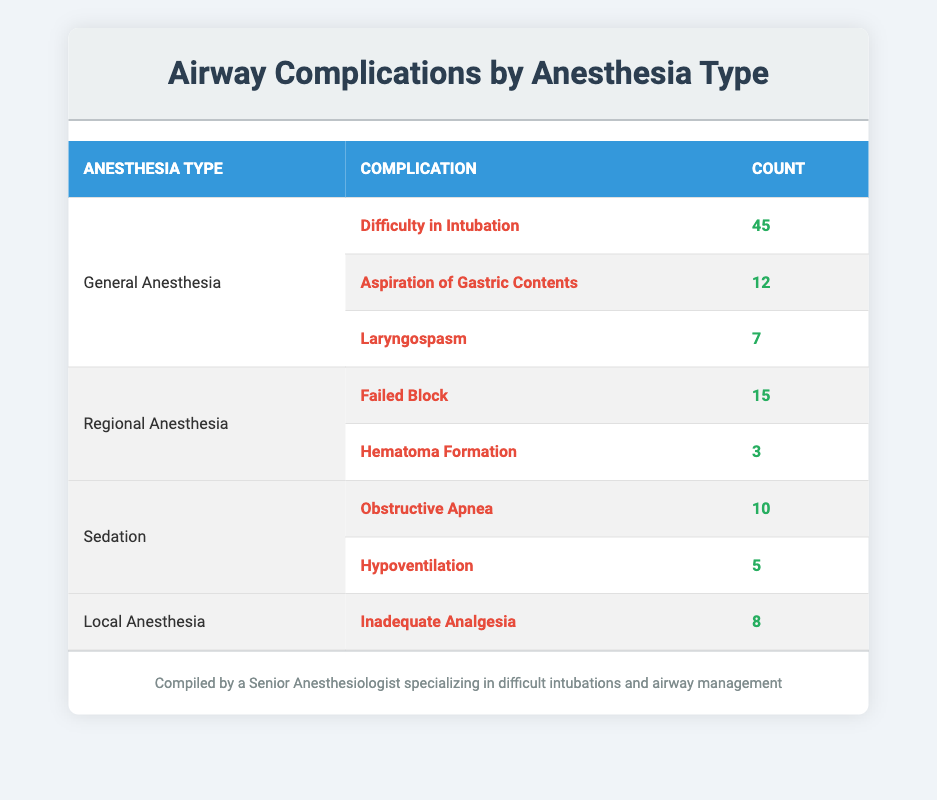What is the total number of airway complications reported for General Anesthesia? To find the total number of airway complications for General Anesthesia, we need to sum the counts for each complication listed under this category: 45 (Difficulty in Intubation) + 12 (Aspiration of Gastric Contents) + 7 (Laryngospasm) = 64.
Answer: 64 Which complication associated with Sedation has a lower count, Obstructive Apnea or Hypoventilation? The counts for Sedation complications are: Obstructive Apnea with a count of 10 and Hypoventilation with a count of 5. Since 5 < 10, Hypoventilation has a lower count.
Answer: Hypoventilation Does Local Anesthesia have any airway complications reported? There is one airway complication reported for Local Anesthesia, which is Inadequate Analgesia. Therefore, Local Anesthesia does have an airway complication.
Answer: Yes What is the average number of airway complications for each type of anesthesia? To calculate the average, first sum the counts for each anesthesia type: General Anesthesia = 64, Regional Anesthesia = 18, Sedation = 15, Local Anesthesia = 8. Then calculate the average across four types: (64 + 18 + 15 + 8) / 4 = 105 / 4 = 26.25.
Answer: 26.25 How many complications are related to Regional Anesthesia that are greater than 10? The complications for Regional Anesthesia are: Failed Block (count 15) and Hematoma Formation (count 3). Only Failed Block is greater than 10.
Answer: 1 